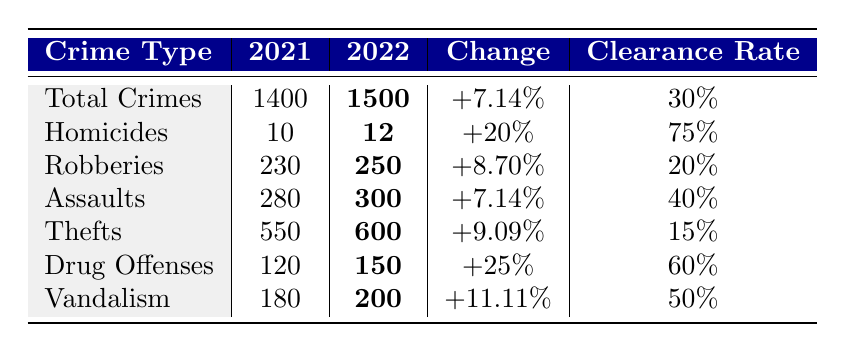What is the total number of crimes reported in Wilmington in 2022? The table specifies that the total crimes for 2022 is bolded and noted as 1500.
Answer: 1500 How many more robberies were reported in 2022 compared to 2021? From the table, the number of robberies in 2021 is 230 and in 2022 is 250. To find the difference, we calculate 250 - 230 = 20.
Answer: 20 What is the clearance rate for homicides in 2022? The table indicates that the clearance rate for homicides in 2022 is noted as 75%.
Answer: 75% Did the number of drug offenses increase from 2021 to 2022? The table shows the number of drug offenses increased from 120 in 2021 to 150 in 2022, which is a positive change. Therefore, it is true that they increased.
Answer: Yes Which type of crime had the highest clearance rate in 2022? By looking at the clearance rates for each crime type, homicides have the highest rate at 75%.
Answer: Homicides What was the percentage increase in thefts from 2021 to 2022? The table states that thefts in 2021 were 550 and in 2022, it’s 600. The increase is calculated as (600 - 550) / 550 * 100 = 9.09%.
Answer: 9.09% If we sum the total number of assaults and vandalism in 2022, what is the result? The table indicates total assaults in 2022 are 300 and vandalism is 200. Adding those gives us 300 + 200 = 500.
Answer: 500 What is the total number of reported homicides and robberies in 2022? The table lists homicides as 12 and robberies as 250 for 2022. Summing these gives us 12 + 250 = 262.
Answer: 262 Is the clearance rate for thefts higher than that for robberies in 2022? The table shows the clearance rate for thefts is 15% and for robberies is 20%. Since 15% is less than 20%, the statement is false.
Answer: No What is the overall change in total crimes from 2021 to 2022? The table notes that total crimes in 2021 were 1400 and in 2022 were 1500. The change is calculated as (1500 - 1400) / 1400 * 100 = 7.14%.
Answer: +7.14% 